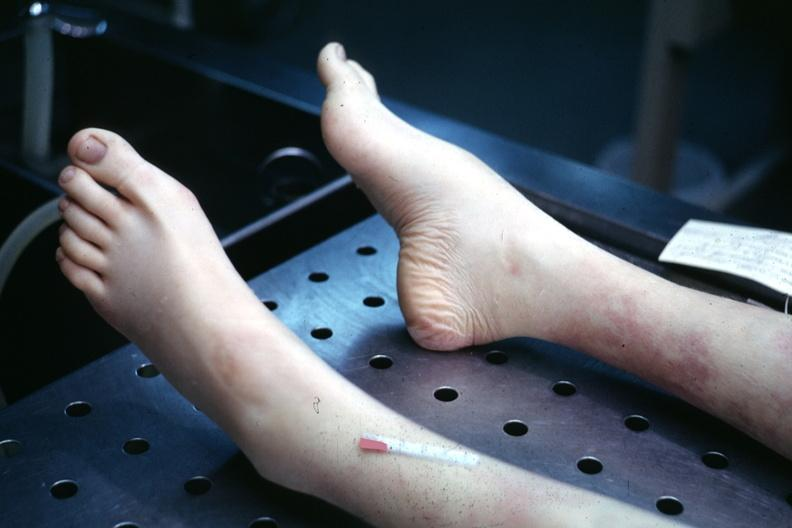re extremities present?
Answer the question using a single word or phrase. Yes 